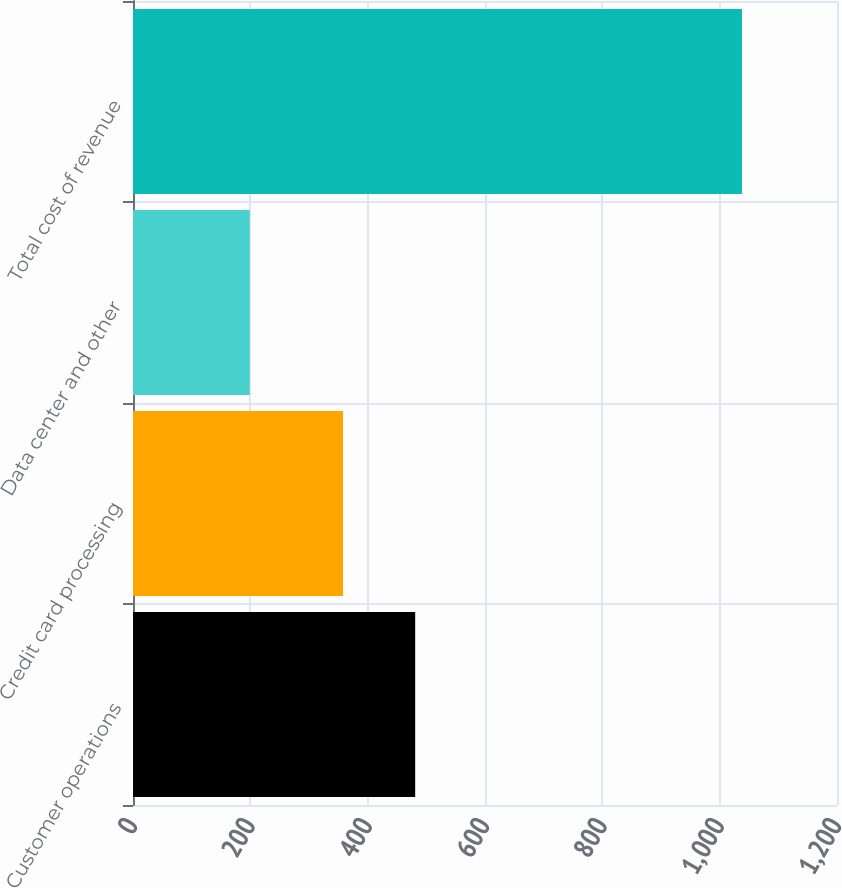Convert chart to OTSL. <chart><loc_0><loc_0><loc_500><loc_500><bar_chart><fcel>Customer operations<fcel>Credit card processing<fcel>Data center and other<fcel>Total cost of revenue<nl><fcel>481<fcel>358<fcel>199<fcel>1038<nl></chart> 